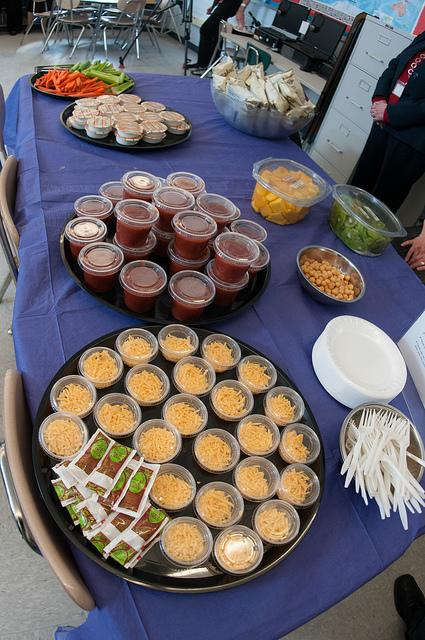What type of building might this be? office 